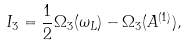<formula> <loc_0><loc_0><loc_500><loc_500>I _ { 3 } = \frac { 1 } { 2 } \Omega _ { 3 } ( \omega _ { L } ) - \Omega _ { 3 } ( A ^ { ( 1 ) } ) ,</formula> 